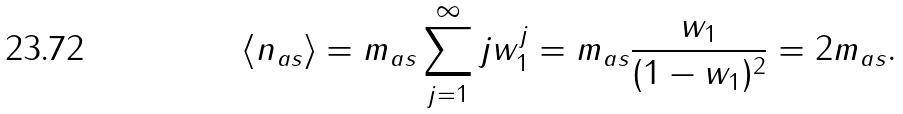Convert formula to latex. <formula><loc_0><loc_0><loc_500><loc_500>\langle n _ { a s } \rangle = m _ { a s } \sum _ { j = 1 } ^ { \infty } j w _ { 1 } ^ { j } = m _ { a s } \frac { w _ { 1 } } { ( 1 - w _ { 1 } ) ^ { 2 } } = 2 m _ { a s } .</formula> 